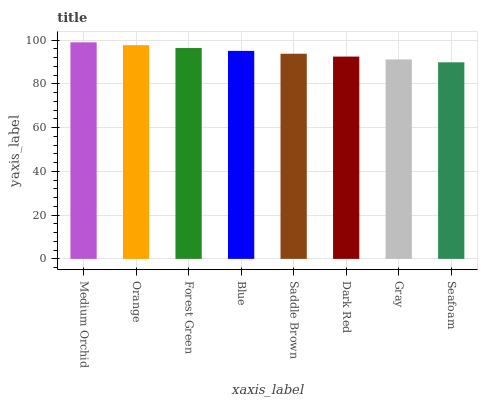Is Seafoam the minimum?
Answer yes or no. Yes. Is Medium Orchid the maximum?
Answer yes or no. Yes. Is Orange the minimum?
Answer yes or no. No. Is Orange the maximum?
Answer yes or no. No. Is Medium Orchid greater than Orange?
Answer yes or no. Yes. Is Orange less than Medium Orchid?
Answer yes or no. Yes. Is Orange greater than Medium Orchid?
Answer yes or no. No. Is Medium Orchid less than Orange?
Answer yes or no. No. Is Blue the high median?
Answer yes or no. Yes. Is Saddle Brown the low median?
Answer yes or no. Yes. Is Forest Green the high median?
Answer yes or no. No. Is Dark Red the low median?
Answer yes or no. No. 